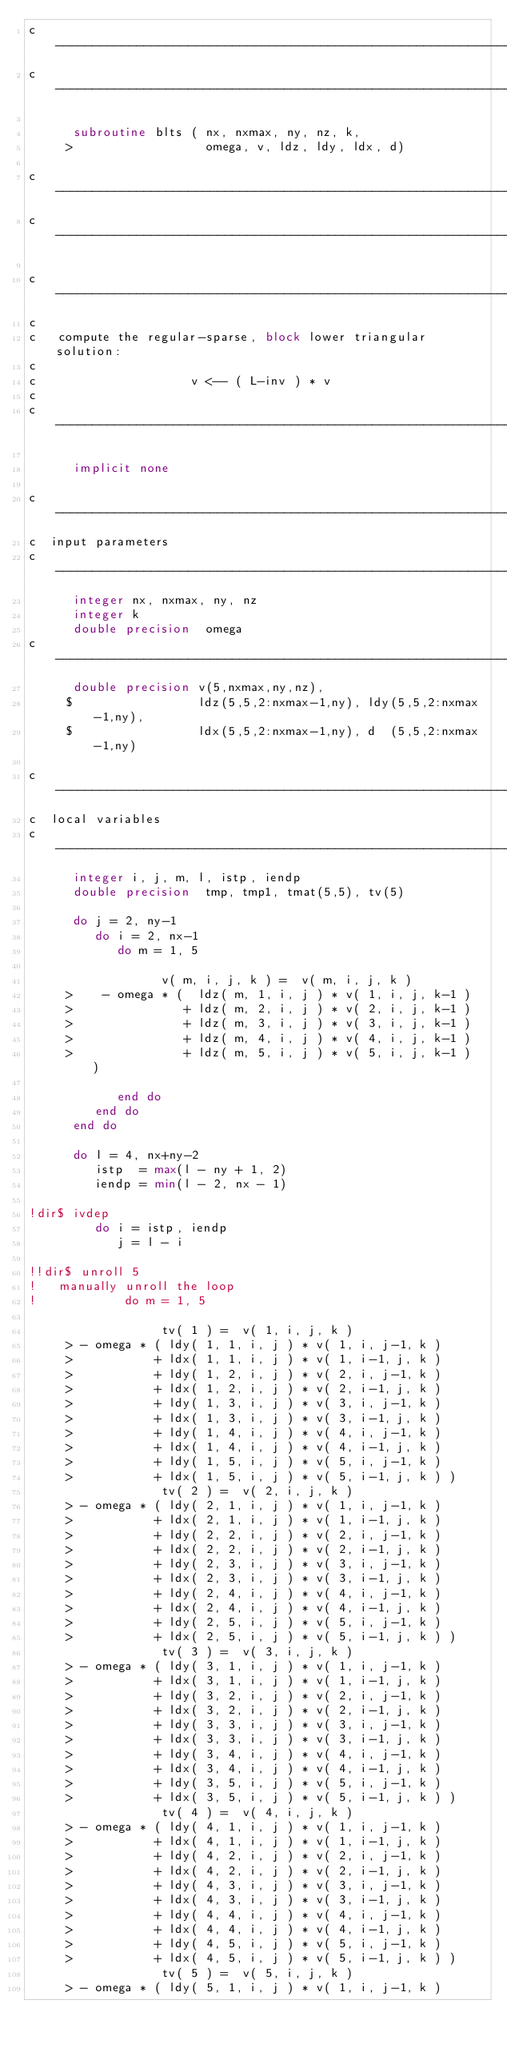<code> <loc_0><loc_0><loc_500><loc_500><_FORTRAN_>c---------------------------------------------------------------------
c---------------------------------------------------------------------

      subroutine blts ( nx, nxmax, ny, nz, k,
     >                  omega, v, ldz, ldy, ldx, d)

c---------------------------------------------------------------------
c---------------------------------------------------------------------

c---------------------------------------------------------------------
c
c   compute the regular-sparse, block lower triangular solution:
c
c                     v <-- ( L-inv ) * v
c
c---------------------------------------------------------------------

      implicit none

c---------------------------------------------------------------------
c  input parameters
c---------------------------------------------------------------------
      integer nx, nxmax, ny, nz 
      integer k
      double precision  omega
c---------------------------------------------------------------------
      double precision v(5,nxmax,ny,nz), 
     $                 ldz(5,5,2:nxmax-1,ny), ldy(5,5,2:nxmax-1,ny), 
     $                 ldx(5,5,2:nxmax-1,ny), d  (5,5,2:nxmax-1,ny)

c---------------------------------------------------------------------
c  local variables
c---------------------------------------------------------------------
      integer i, j, m, l, istp, iendp
      double precision  tmp, tmp1, tmat(5,5), tv(5)

      do j = 2, ny-1
         do i = 2, nx-1
            do m = 1, 5

                  v( m, i, j, k ) =  v( m, i, j, k )
     >    - omega * (  ldz( m, 1, i, j ) * v( 1, i, j, k-1 )
     >               + ldz( m, 2, i, j ) * v( 2, i, j, k-1 )
     >               + ldz( m, 3, i, j ) * v( 3, i, j, k-1 )
     >               + ldz( m, 4, i, j ) * v( 4, i, j, k-1 )
     >               + ldz( m, 5, i, j ) * v( 5, i, j, k-1 )  )

            end do
         end do
      end do

      do l = 4, nx+ny-2
         istp  = max(l - ny + 1, 2)
         iendp = min(l - 2, nx - 1)

!dir$ ivdep
         do i = istp, iendp
            j = l - i

!!dir$ unroll 5
!   manually unroll the loop
!            do m = 1, 5

                  tv( 1 ) =  v( 1, i, j, k )
     > - omega * ( ldy( 1, 1, i, j ) * v( 1, i, j-1, k )
     >           + ldx( 1, 1, i, j ) * v( 1, i-1, j, k )
     >           + ldy( 1, 2, i, j ) * v( 2, i, j-1, k )
     >           + ldx( 1, 2, i, j ) * v( 2, i-1, j, k )
     >           + ldy( 1, 3, i, j ) * v( 3, i, j-1, k )
     >           + ldx( 1, 3, i, j ) * v( 3, i-1, j, k )
     >           + ldy( 1, 4, i, j ) * v( 4, i, j-1, k )
     >           + ldx( 1, 4, i, j ) * v( 4, i-1, j, k )
     >           + ldy( 1, 5, i, j ) * v( 5, i, j-1, k )
     >           + ldx( 1, 5, i, j ) * v( 5, i-1, j, k ) )
                  tv( 2 ) =  v( 2, i, j, k )
     > - omega * ( ldy( 2, 1, i, j ) * v( 1, i, j-1, k )
     >           + ldx( 2, 1, i, j ) * v( 1, i-1, j, k )
     >           + ldy( 2, 2, i, j ) * v( 2, i, j-1, k )
     >           + ldx( 2, 2, i, j ) * v( 2, i-1, j, k )
     >           + ldy( 2, 3, i, j ) * v( 3, i, j-1, k )
     >           + ldx( 2, 3, i, j ) * v( 3, i-1, j, k )
     >           + ldy( 2, 4, i, j ) * v( 4, i, j-1, k )
     >           + ldx( 2, 4, i, j ) * v( 4, i-1, j, k )
     >           + ldy( 2, 5, i, j ) * v( 5, i, j-1, k )
     >           + ldx( 2, 5, i, j ) * v( 5, i-1, j, k ) )
                  tv( 3 ) =  v( 3, i, j, k )
     > - omega * ( ldy( 3, 1, i, j ) * v( 1, i, j-1, k )
     >           + ldx( 3, 1, i, j ) * v( 1, i-1, j, k )
     >           + ldy( 3, 2, i, j ) * v( 2, i, j-1, k )
     >           + ldx( 3, 2, i, j ) * v( 2, i-1, j, k )
     >           + ldy( 3, 3, i, j ) * v( 3, i, j-1, k )
     >           + ldx( 3, 3, i, j ) * v( 3, i-1, j, k )
     >           + ldy( 3, 4, i, j ) * v( 4, i, j-1, k )
     >           + ldx( 3, 4, i, j ) * v( 4, i-1, j, k )
     >           + ldy( 3, 5, i, j ) * v( 5, i, j-1, k )
     >           + ldx( 3, 5, i, j ) * v( 5, i-1, j, k ) )
                  tv( 4 ) =  v( 4, i, j, k )
     > - omega * ( ldy( 4, 1, i, j ) * v( 1, i, j-1, k )
     >           + ldx( 4, 1, i, j ) * v( 1, i-1, j, k )
     >           + ldy( 4, 2, i, j ) * v( 2, i, j-1, k )
     >           + ldx( 4, 2, i, j ) * v( 2, i-1, j, k )
     >           + ldy( 4, 3, i, j ) * v( 3, i, j-1, k )
     >           + ldx( 4, 3, i, j ) * v( 3, i-1, j, k )
     >           + ldy( 4, 4, i, j ) * v( 4, i, j-1, k )
     >           + ldx( 4, 4, i, j ) * v( 4, i-1, j, k )
     >           + ldy( 4, 5, i, j ) * v( 5, i, j-1, k )
     >           + ldx( 4, 5, i, j ) * v( 5, i-1, j, k ) )
                  tv( 5 ) =  v( 5, i, j, k )
     > - omega * ( ldy( 5, 1, i, j ) * v( 1, i, j-1, k )</code> 